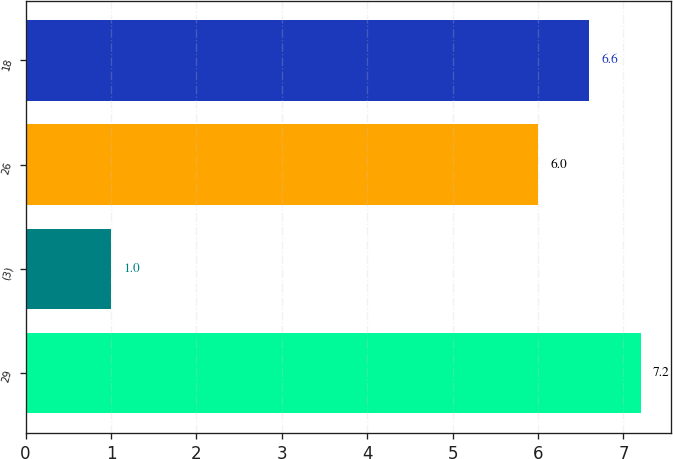Convert chart to OTSL. <chart><loc_0><loc_0><loc_500><loc_500><bar_chart><fcel>29<fcel>(3)<fcel>26<fcel>18<nl><fcel>7.2<fcel>1<fcel>6<fcel>6.6<nl></chart> 